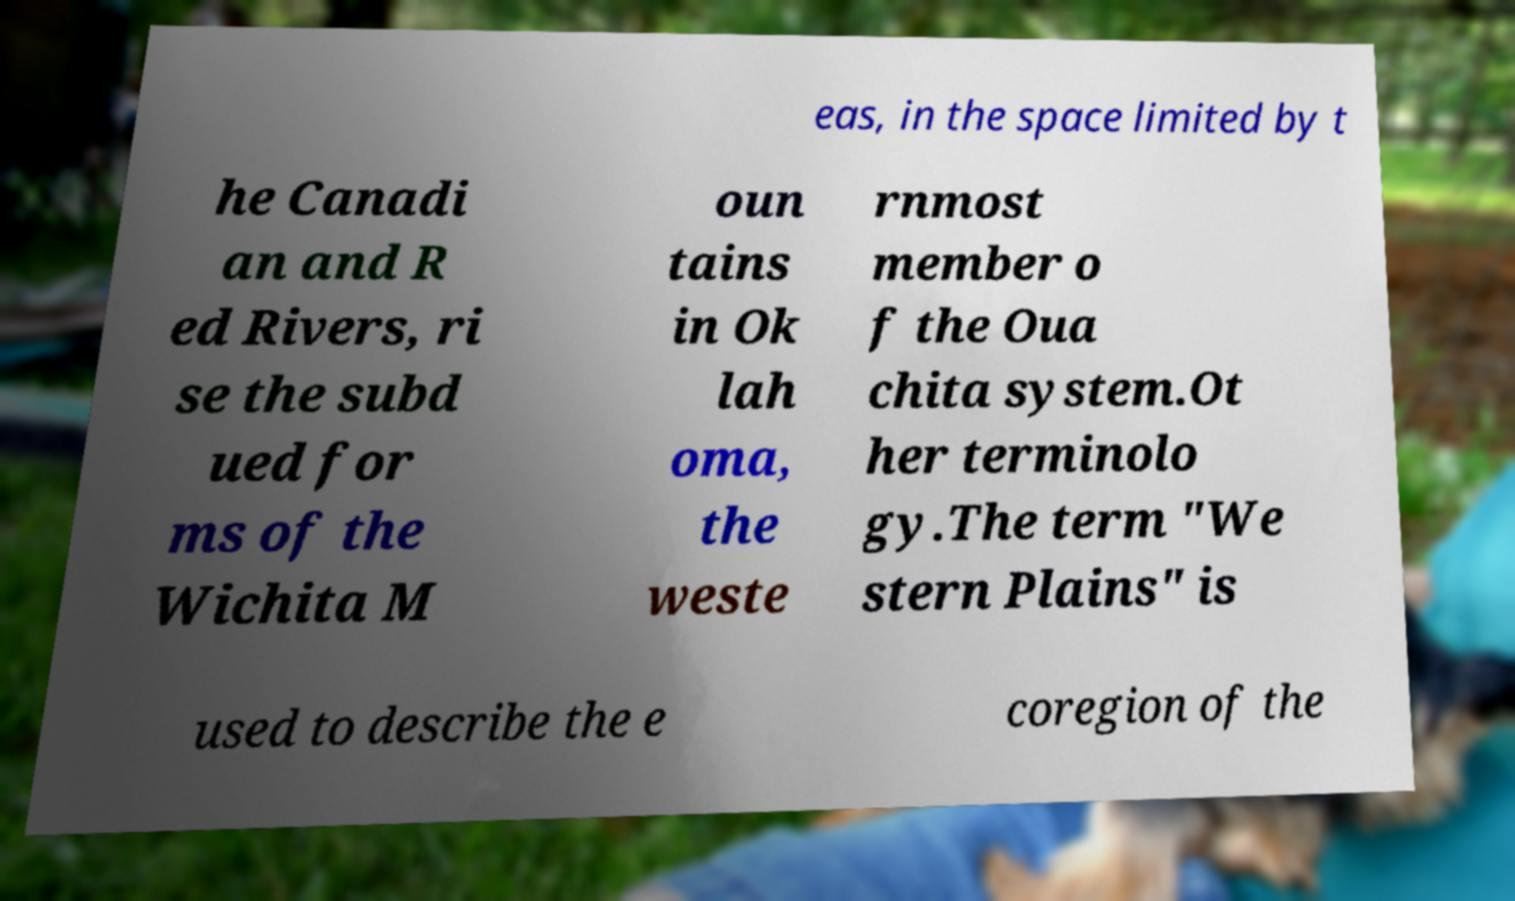Could you assist in decoding the text presented in this image and type it out clearly? eas, in the space limited by t he Canadi an and R ed Rivers, ri se the subd ued for ms of the Wichita M oun tains in Ok lah oma, the weste rnmost member o f the Oua chita system.Ot her terminolo gy.The term "We stern Plains" is used to describe the e coregion of the 